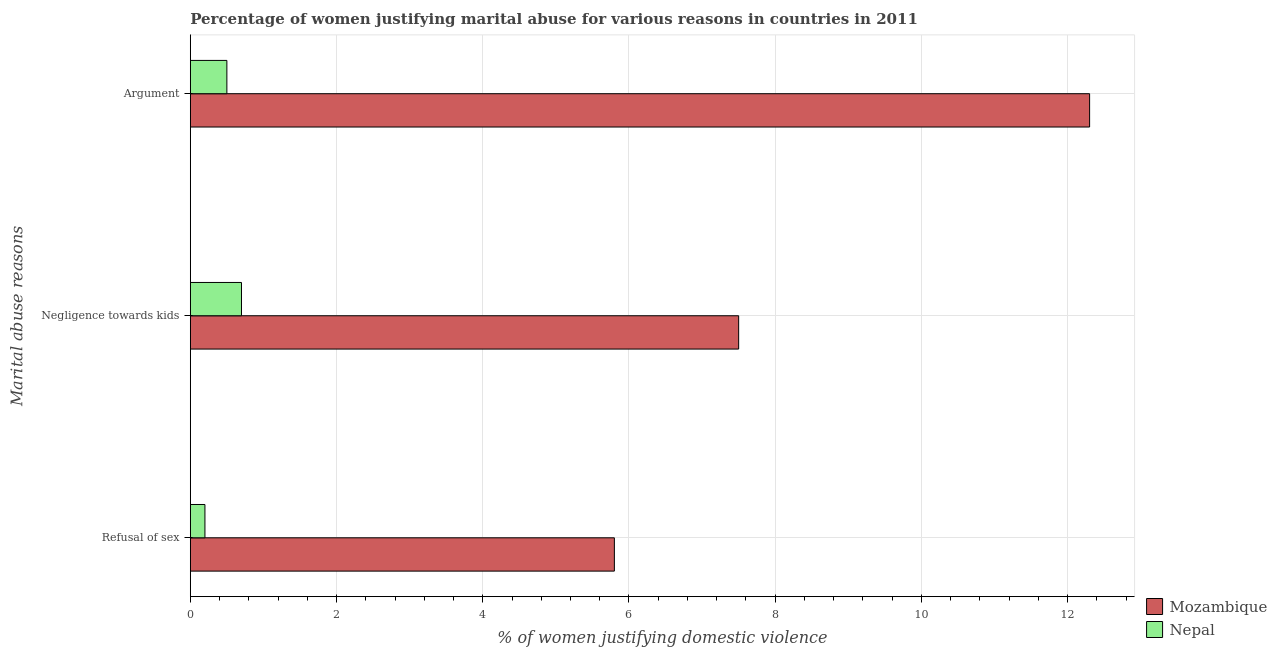How many different coloured bars are there?
Provide a succinct answer. 2. Are the number of bars on each tick of the Y-axis equal?
Provide a succinct answer. Yes. How many bars are there on the 2nd tick from the top?
Make the answer very short. 2. How many bars are there on the 3rd tick from the bottom?
Give a very brief answer. 2. What is the label of the 3rd group of bars from the top?
Ensure brevity in your answer.  Refusal of sex. What is the percentage of women justifying domestic violence due to arguments in Mozambique?
Offer a very short reply. 12.3. Across all countries, what is the maximum percentage of women justifying domestic violence due to negligence towards kids?
Make the answer very short. 7.5. Across all countries, what is the minimum percentage of women justifying domestic violence due to negligence towards kids?
Offer a very short reply. 0.7. In which country was the percentage of women justifying domestic violence due to negligence towards kids maximum?
Keep it short and to the point. Mozambique. In which country was the percentage of women justifying domestic violence due to arguments minimum?
Give a very brief answer. Nepal. What is the difference between the percentage of women justifying domestic violence due to negligence towards kids in Nepal and that in Mozambique?
Ensure brevity in your answer.  -6.8. What is the difference between the percentage of women justifying domestic violence due to negligence towards kids in Mozambique and the percentage of women justifying domestic violence due to refusal of sex in Nepal?
Your response must be concise. 7.3. What is the difference between the percentage of women justifying domestic violence due to arguments and percentage of women justifying domestic violence due to negligence towards kids in Nepal?
Your answer should be very brief. -0.2. In how many countries, is the percentage of women justifying domestic violence due to arguments greater than 2 %?
Provide a succinct answer. 1. What is the ratio of the percentage of women justifying domestic violence due to negligence towards kids in Nepal to that in Mozambique?
Give a very brief answer. 0.09. Is the difference between the percentage of women justifying domestic violence due to arguments in Nepal and Mozambique greater than the difference between the percentage of women justifying domestic violence due to negligence towards kids in Nepal and Mozambique?
Offer a terse response. No. What is the difference between the highest and the second highest percentage of women justifying domestic violence due to negligence towards kids?
Provide a short and direct response. 6.8. What does the 2nd bar from the top in Negligence towards kids represents?
Provide a succinct answer. Mozambique. What does the 2nd bar from the bottom in Refusal of sex represents?
Provide a short and direct response. Nepal. Is it the case that in every country, the sum of the percentage of women justifying domestic violence due to refusal of sex and percentage of women justifying domestic violence due to negligence towards kids is greater than the percentage of women justifying domestic violence due to arguments?
Offer a very short reply. Yes. What is the difference between two consecutive major ticks on the X-axis?
Your answer should be compact. 2. Does the graph contain grids?
Your answer should be compact. Yes. Where does the legend appear in the graph?
Make the answer very short. Bottom right. What is the title of the graph?
Offer a very short reply. Percentage of women justifying marital abuse for various reasons in countries in 2011. Does "Myanmar" appear as one of the legend labels in the graph?
Ensure brevity in your answer.  No. What is the label or title of the X-axis?
Keep it short and to the point. % of women justifying domestic violence. What is the label or title of the Y-axis?
Offer a terse response. Marital abuse reasons. What is the % of women justifying domestic violence of Mozambique in Refusal of sex?
Your answer should be compact. 5.8. What is the % of women justifying domestic violence in Nepal in Negligence towards kids?
Ensure brevity in your answer.  0.7. What is the % of women justifying domestic violence of Mozambique in Argument?
Offer a very short reply. 12.3. Across all Marital abuse reasons, what is the maximum % of women justifying domestic violence of Mozambique?
Provide a succinct answer. 12.3. Across all Marital abuse reasons, what is the minimum % of women justifying domestic violence of Mozambique?
Ensure brevity in your answer.  5.8. Across all Marital abuse reasons, what is the minimum % of women justifying domestic violence of Nepal?
Give a very brief answer. 0.2. What is the total % of women justifying domestic violence in Mozambique in the graph?
Offer a terse response. 25.6. What is the total % of women justifying domestic violence of Nepal in the graph?
Ensure brevity in your answer.  1.4. What is the difference between the % of women justifying domestic violence in Mozambique in Refusal of sex and that in Negligence towards kids?
Offer a terse response. -1.7. What is the difference between the % of women justifying domestic violence of Mozambique in Negligence towards kids and that in Argument?
Your answer should be very brief. -4.8. What is the difference between the % of women justifying domestic violence in Mozambique in Refusal of sex and the % of women justifying domestic violence in Nepal in Argument?
Make the answer very short. 5.3. What is the average % of women justifying domestic violence in Mozambique per Marital abuse reasons?
Ensure brevity in your answer.  8.53. What is the average % of women justifying domestic violence in Nepal per Marital abuse reasons?
Provide a succinct answer. 0.47. What is the difference between the % of women justifying domestic violence of Mozambique and % of women justifying domestic violence of Nepal in Argument?
Offer a very short reply. 11.8. What is the ratio of the % of women justifying domestic violence in Mozambique in Refusal of sex to that in Negligence towards kids?
Offer a very short reply. 0.77. What is the ratio of the % of women justifying domestic violence of Nepal in Refusal of sex to that in Negligence towards kids?
Keep it short and to the point. 0.29. What is the ratio of the % of women justifying domestic violence of Mozambique in Refusal of sex to that in Argument?
Provide a succinct answer. 0.47. What is the ratio of the % of women justifying domestic violence of Mozambique in Negligence towards kids to that in Argument?
Make the answer very short. 0.61. What is the ratio of the % of women justifying domestic violence in Nepal in Negligence towards kids to that in Argument?
Make the answer very short. 1.4. What is the difference between the highest and the second highest % of women justifying domestic violence of Nepal?
Offer a very short reply. 0.2. What is the difference between the highest and the lowest % of women justifying domestic violence in Nepal?
Your answer should be very brief. 0.5. 